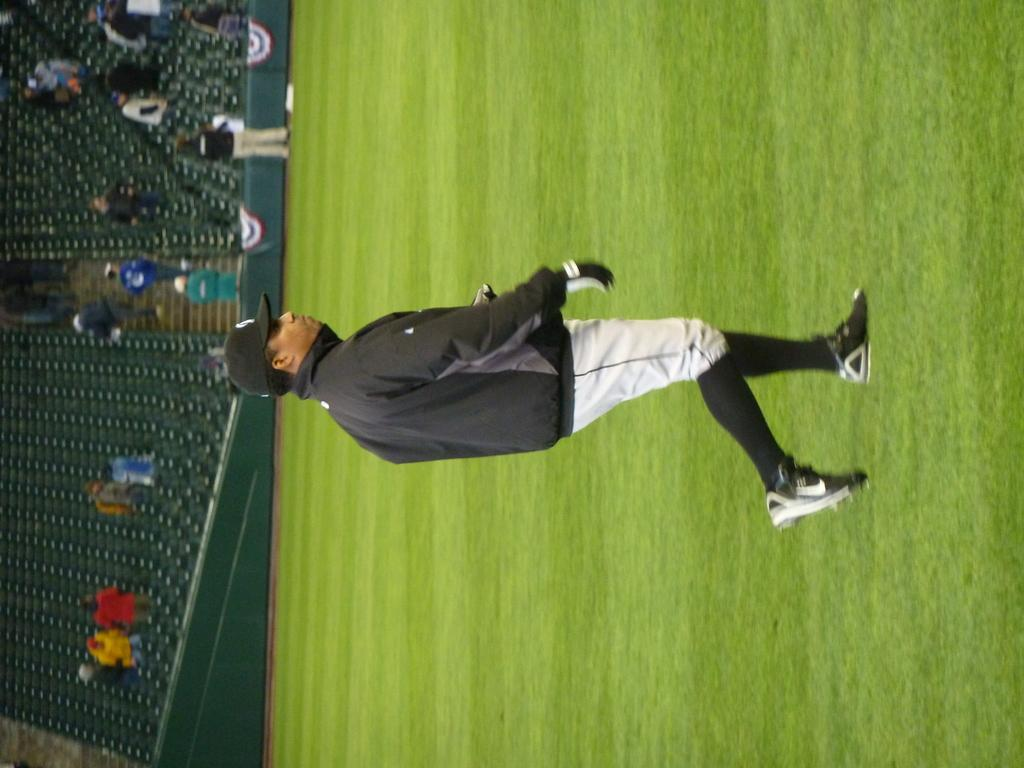What is the main action of the person in the image? There is a person walking in the image. What surface is the person walking on? The person is walking on the ground. What objects can be seen on the left side of the image? There are chairs on the left side of the image. What type of location does the image appear to depict? The setting appears to be a stadium. How many people are present in the image? There are people present in the image. What type of fruit can be seen growing on the chairs in the image? There are no fruits, such as oranges or tomatoes, growing on the chairs in the image. What kind of flower is blooming on the person walking in the image? There are no flowers visible on the person walking in the image. 